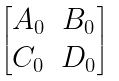Convert formula to latex. <formula><loc_0><loc_0><loc_500><loc_500>\begin{bmatrix} A _ { 0 } & B _ { 0 } \\ C _ { 0 } & D _ { 0 } \end{bmatrix}</formula> 